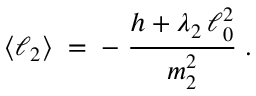<formula> <loc_0><loc_0><loc_500><loc_500>\langle \ell _ { 2 } \rangle \, = \, - \, \frac { h + \lambda _ { 2 } \, \ell _ { 0 } ^ { 2 } } { m _ { 2 } ^ { 2 } } \, .</formula> 